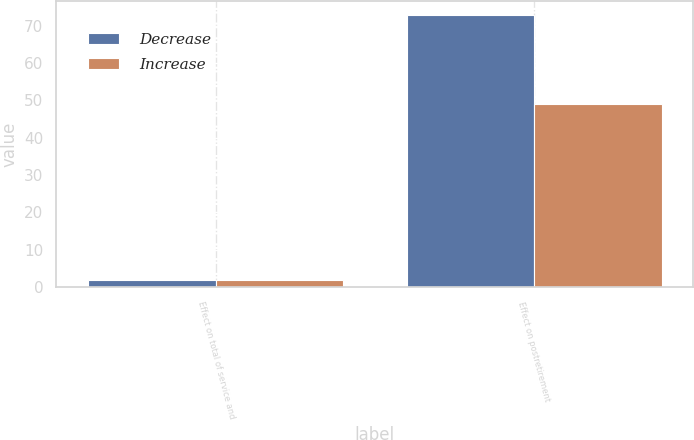Convert chart to OTSL. <chart><loc_0><loc_0><loc_500><loc_500><stacked_bar_chart><ecel><fcel>Effect on total of service and<fcel>Effect on postretirement<nl><fcel>Decrease<fcel>2<fcel>73<nl><fcel>Increase<fcel>2<fcel>49<nl></chart> 